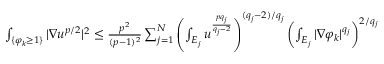<formula> <loc_0><loc_0><loc_500><loc_500>\begin{array} { r } { \int _ { \{ \varphi _ { k } \geq 1 \} } | \nabla u ^ { p / 2 } | ^ { 2 } \leq \frac { p ^ { 2 } } { ( p - 1 ) ^ { 2 } } \sum _ { j = 1 } ^ { N } \left ( \int _ { E _ { j } } u ^ { \frac { p q _ { j } } { q _ { j } - 2 } } \right ) ^ { ( q _ { j } - 2 ) / q _ { j } } \left ( \int _ { E _ { j } } | \nabla \varphi _ { k } | ^ { q _ { j } } \right ) ^ { 2 / q _ { j } } } \end{array}</formula> 